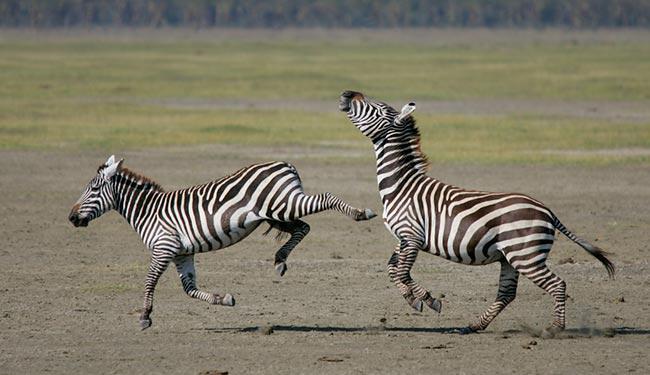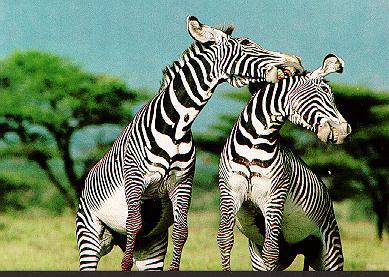The first image is the image on the left, the second image is the image on the right. For the images shown, is this caption "Each image contains exactly two zebras, and the left image shows one zebra standing on its hind legs face-to-face and in contact with another zebra." true? Answer yes or no. No. The first image is the image on the left, the second image is the image on the right. Given the left and right images, does the statement "The left and right image contains the same number of zebras with at least two looking at two face to face." hold true? Answer yes or no. No. 